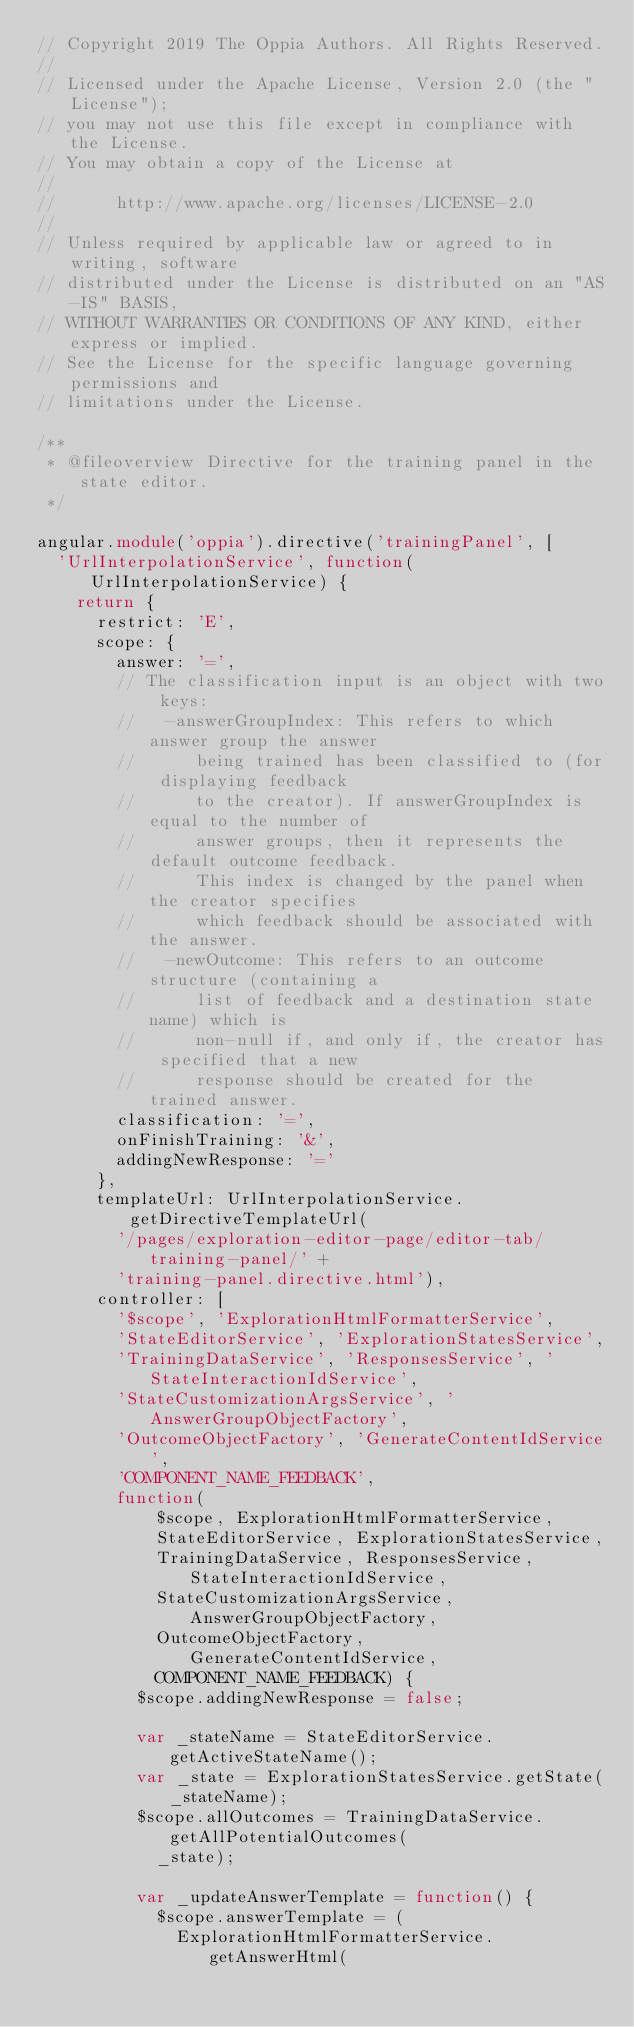Convert code to text. <code><loc_0><loc_0><loc_500><loc_500><_TypeScript_>// Copyright 2019 The Oppia Authors. All Rights Reserved.
//
// Licensed under the Apache License, Version 2.0 (the "License");
// you may not use this file except in compliance with the License.
// You may obtain a copy of the License at
//
//      http://www.apache.org/licenses/LICENSE-2.0
//
// Unless required by applicable law or agreed to in writing, software
// distributed under the License is distributed on an "AS-IS" BASIS,
// WITHOUT WARRANTIES OR CONDITIONS OF ANY KIND, either express or implied.
// See the License for the specific language governing permissions and
// limitations under the License.

/**
 * @fileoverview Directive for the training panel in the state editor.
 */

angular.module('oppia').directive('trainingPanel', [
  'UrlInterpolationService', function(UrlInterpolationService) {
    return {
      restrict: 'E',
      scope: {
        answer: '=',
        // The classification input is an object with two keys:
        //   -answerGroupIndex: This refers to which answer group the answer
        //      being trained has been classified to (for displaying feedback
        //      to the creator). If answerGroupIndex is equal to the number of
        //      answer groups, then it represents the default outcome feedback.
        //      This index is changed by the panel when the creator specifies
        //      which feedback should be associated with the answer.
        //   -newOutcome: This refers to an outcome structure (containing a
        //      list of feedback and a destination state name) which is
        //      non-null if, and only if, the creator has specified that a new
        //      response should be created for the trained answer.
        classification: '=',
        onFinishTraining: '&',
        addingNewResponse: '='
      },
      templateUrl: UrlInterpolationService.getDirectiveTemplateUrl(
        '/pages/exploration-editor-page/editor-tab/training-panel/' +
        'training-panel.directive.html'),
      controller: [
        '$scope', 'ExplorationHtmlFormatterService',
        'StateEditorService', 'ExplorationStatesService',
        'TrainingDataService', 'ResponsesService', 'StateInteractionIdService',
        'StateCustomizationArgsService', 'AnswerGroupObjectFactory',
        'OutcomeObjectFactory', 'GenerateContentIdService',
        'COMPONENT_NAME_FEEDBACK',
        function(
            $scope, ExplorationHtmlFormatterService,
            StateEditorService, ExplorationStatesService,
            TrainingDataService, ResponsesService, StateInteractionIdService,
            StateCustomizationArgsService, AnswerGroupObjectFactory,
            OutcomeObjectFactory, GenerateContentIdService,
            COMPONENT_NAME_FEEDBACK) {
          $scope.addingNewResponse = false;

          var _stateName = StateEditorService.getActiveStateName();
          var _state = ExplorationStatesService.getState(_stateName);
          $scope.allOutcomes = TrainingDataService.getAllPotentialOutcomes(
            _state);

          var _updateAnswerTemplate = function() {
            $scope.answerTemplate = (
              ExplorationHtmlFormatterService.getAnswerHtml(</code> 